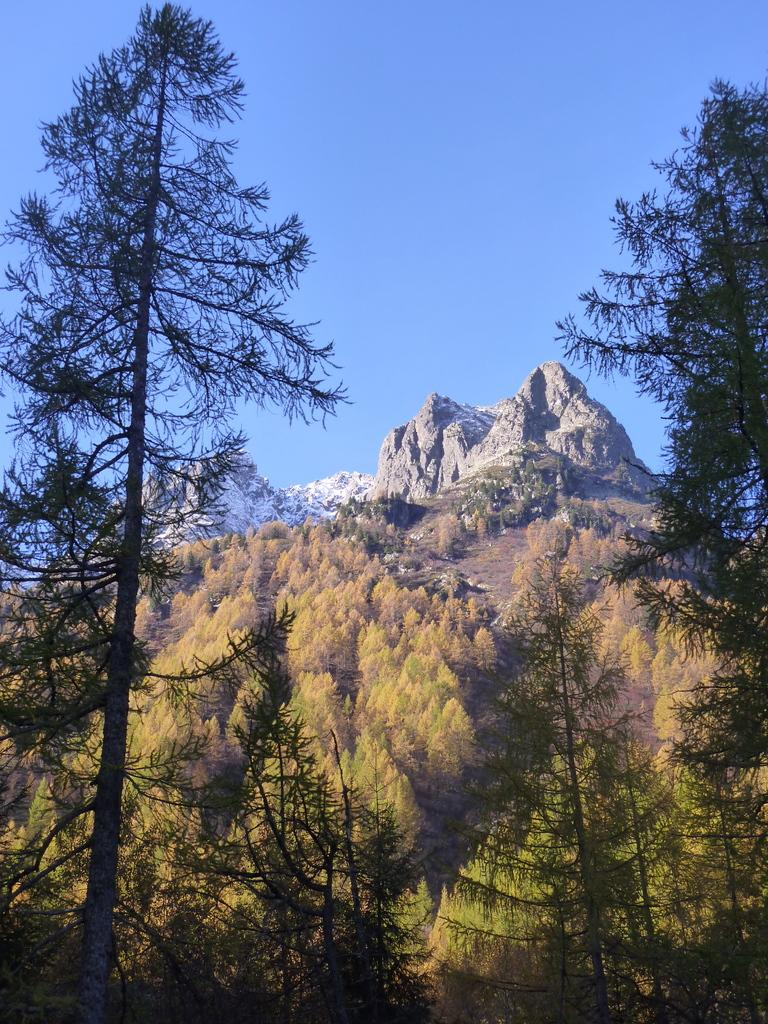What type of vegetation can be seen in the image? There are trees in the image. What geographical feature is present in the image? There is a hill in the image. What is visible at the top of the image? The sky is visible at the top of the image. Can you tell me how many pots are placed on the hill in the image? There is no pot present in the image; it only features trees and a hill. What type of request is being made by the trees in the image? There is no request being made by the trees in the image, as they are inanimate objects. 